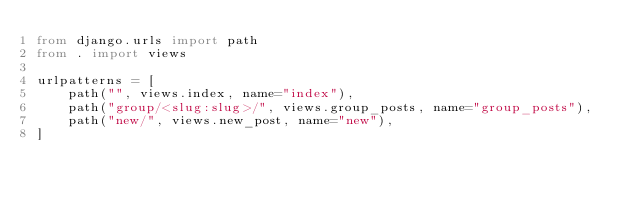Convert code to text. <code><loc_0><loc_0><loc_500><loc_500><_Python_>from django.urls import path
from . import views

urlpatterns = [
    path("", views.index, name="index"),
    path("group/<slug:slug>/", views.group_posts, name="group_posts"),
    path("new/", views.new_post, name="new"),
]
</code> 